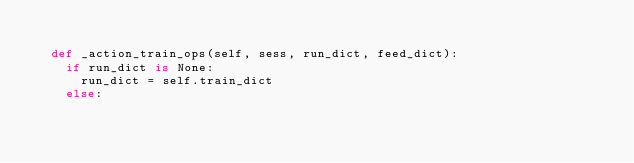<code> <loc_0><loc_0><loc_500><loc_500><_Python_>
  def _action_train_ops(self, sess, run_dict, feed_dict):
    if run_dict is None:
      run_dict = self.train_dict
    else:</code> 